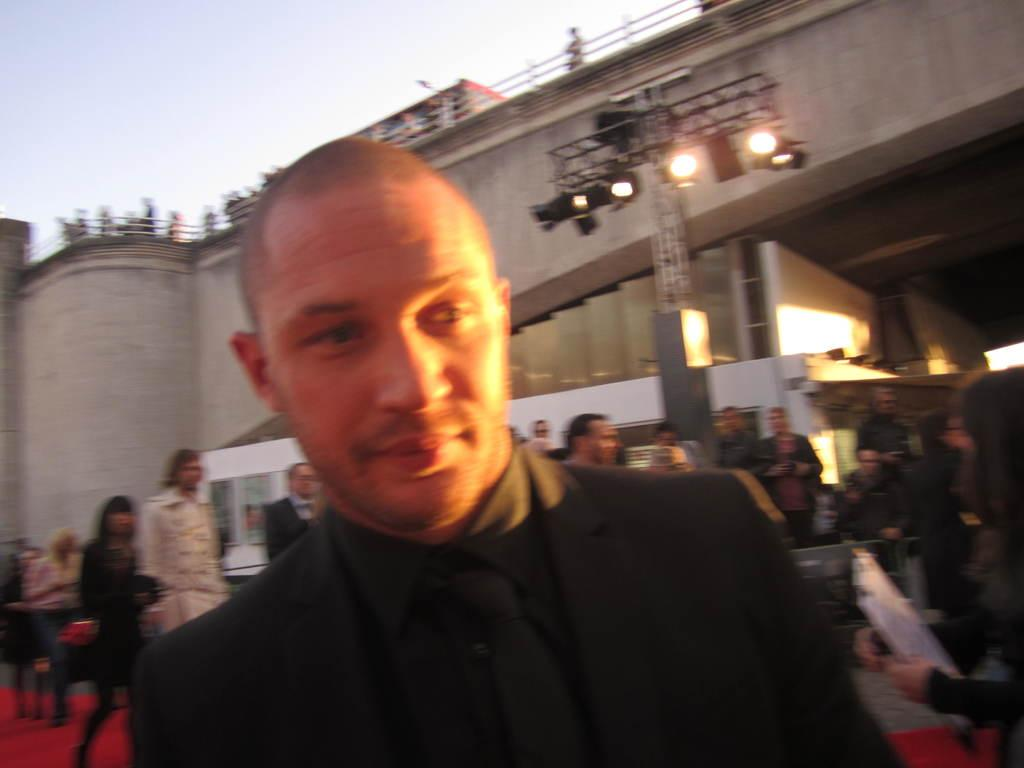What is the person in the foreground of the image wearing? The person in the image is wearing a black color dress. Can you describe the people in the background of the image? There are other persons in the background of the image, some of whom are standing and some are walking. What can be seen in the background of the image? There are lights and a bridge visible in the background of the image. What sound does the horse make in the image? There is no horse present in the image. What thought is the person in the image having? There is no indication of the person's thoughts in the image. 